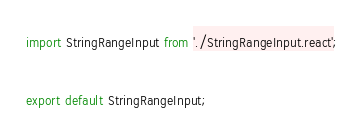Convert code to text. <code><loc_0><loc_0><loc_500><loc_500><_JavaScript_>import StringRangeInput from './StringRangeInput.react';

export default StringRangeInput;
</code> 